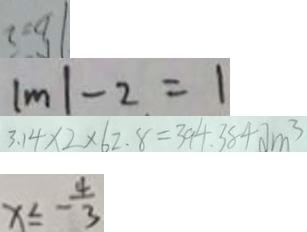<formula> <loc_0><loc_0><loc_500><loc_500>b = 2 
 \vert m \vert - 2 = 1 
 3 . 1 4 \times 2 \times 6 2 . 8 = 3 9 4 . 3 8 4 d m ^ { 3 } 
 x \leq - \frac { 4 } { 3 }</formula> 